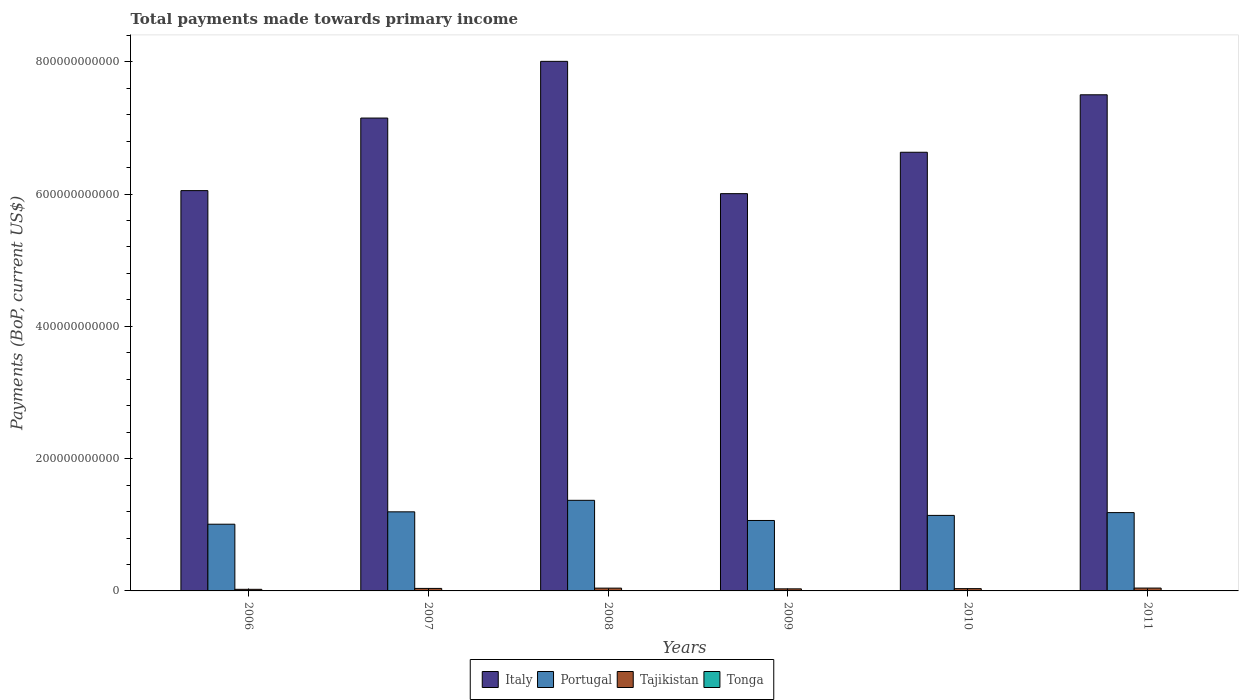How many groups of bars are there?
Your answer should be compact. 6. Are the number of bars on each tick of the X-axis equal?
Make the answer very short. Yes. In how many cases, is the number of bars for a given year not equal to the number of legend labels?
Ensure brevity in your answer.  0. What is the total payments made towards primary income in Tajikistan in 2006?
Your response must be concise. 2.43e+09. Across all years, what is the maximum total payments made towards primary income in Italy?
Keep it short and to the point. 8.01e+11. Across all years, what is the minimum total payments made towards primary income in Tajikistan?
Your response must be concise. 2.43e+09. In which year was the total payments made towards primary income in Tajikistan maximum?
Provide a succinct answer. 2011. What is the total total payments made towards primary income in Italy in the graph?
Ensure brevity in your answer.  4.13e+12. What is the difference between the total payments made towards primary income in Tajikistan in 2007 and that in 2010?
Make the answer very short. 3.23e+08. What is the difference between the total payments made towards primary income in Tonga in 2008 and the total payments made towards primary income in Tajikistan in 2010?
Your answer should be compact. -3.21e+09. What is the average total payments made towards primary income in Portugal per year?
Offer a very short reply. 1.16e+11. In the year 2008, what is the difference between the total payments made towards primary income in Italy and total payments made towards primary income in Portugal?
Give a very brief answer. 6.64e+11. In how many years, is the total payments made towards primary income in Tajikistan greater than 600000000000 US$?
Provide a succinct answer. 0. What is the ratio of the total payments made towards primary income in Italy in 2006 to that in 2010?
Your response must be concise. 0.91. Is the total payments made towards primary income in Tonga in 2009 less than that in 2010?
Provide a succinct answer. No. What is the difference between the highest and the second highest total payments made towards primary income in Italy?
Offer a terse response. 5.06e+1. What is the difference between the highest and the lowest total payments made towards primary income in Italy?
Keep it short and to the point. 2.00e+11. In how many years, is the total payments made towards primary income in Tajikistan greater than the average total payments made towards primary income in Tajikistan taken over all years?
Keep it short and to the point. 3. What does the 3rd bar from the left in 2010 represents?
Ensure brevity in your answer.  Tajikistan. What does the 3rd bar from the right in 2006 represents?
Make the answer very short. Portugal. Is it the case that in every year, the sum of the total payments made towards primary income in Italy and total payments made towards primary income in Tonga is greater than the total payments made towards primary income in Portugal?
Make the answer very short. Yes. Are all the bars in the graph horizontal?
Offer a terse response. No. How many years are there in the graph?
Offer a terse response. 6. What is the difference between two consecutive major ticks on the Y-axis?
Give a very brief answer. 2.00e+11. Does the graph contain grids?
Provide a succinct answer. No. Where does the legend appear in the graph?
Make the answer very short. Bottom center. How many legend labels are there?
Offer a very short reply. 4. How are the legend labels stacked?
Your answer should be very brief. Horizontal. What is the title of the graph?
Your answer should be compact. Total payments made towards primary income. Does "United Kingdom" appear as one of the legend labels in the graph?
Provide a succinct answer. No. What is the label or title of the X-axis?
Your answer should be very brief. Years. What is the label or title of the Y-axis?
Ensure brevity in your answer.  Payments (BoP, current US$). What is the Payments (BoP, current US$) of Italy in 2006?
Make the answer very short. 6.05e+11. What is the Payments (BoP, current US$) in Portugal in 2006?
Offer a very short reply. 1.01e+11. What is the Payments (BoP, current US$) in Tajikistan in 2006?
Give a very brief answer. 2.43e+09. What is the Payments (BoP, current US$) in Tonga in 2006?
Provide a short and direct response. 1.74e+08. What is the Payments (BoP, current US$) in Italy in 2007?
Provide a succinct answer. 7.15e+11. What is the Payments (BoP, current US$) in Portugal in 2007?
Your answer should be compact. 1.20e+11. What is the Payments (BoP, current US$) in Tajikistan in 2007?
Ensure brevity in your answer.  3.78e+09. What is the Payments (BoP, current US$) in Tonga in 2007?
Provide a succinct answer. 2.03e+08. What is the Payments (BoP, current US$) in Italy in 2008?
Make the answer very short. 8.01e+11. What is the Payments (BoP, current US$) of Portugal in 2008?
Make the answer very short. 1.37e+11. What is the Payments (BoP, current US$) of Tajikistan in 2008?
Make the answer very short. 4.23e+09. What is the Payments (BoP, current US$) in Tonga in 2008?
Your answer should be very brief. 2.51e+08. What is the Payments (BoP, current US$) of Italy in 2009?
Provide a succinct answer. 6.01e+11. What is the Payments (BoP, current US$) of Portugal in 2009?
Offer a very short reply. 1.07e+11. What is the Payments (BoP, current US$) in Tajikistan in 2009?
Make the answer very short. 3.14e+09. What is the Payments (BoP, current US$) in Tonga in 2009?
Offer a terse response. 2.45e+08. What is the Payments (BoP, current US$) in Italy in 2010?
Provide a short and direct response. 6.63e+11. What is the Payments (BoP, current US$) in Portugal in 2010?
Provide a short and direct response. 1.14e+11. What is the Payments (BoP, current US$) in Tajikistan in 2010?
Provide a short and direct response. 3.46e+09. What is the Payments (BoP, current US$) of Tonga in 2010?
Give a very brief answer. 2.33e+08. What is the Payments (BoP, current US$) of Italy in 2011?
Provide a succinct answer. 7.50e+11. What is the Payments (BoP, current US$) in Portugal in 2011?
Offer a very short reply. 1.18e+11. What is the Payments (BoP, current US$) of Tajikistan in 2011?
Your answer should be very brief. 4.32e+09. What is the Payments (BoP, current US$) in Tonga in 2011?
Your response must be concise. 2.87e+08. Across all years, what is the maximum Payments (BoP, current US$) in Italy?
Your answer should be very brief. 8.01e+11. Across all years, what is the maximum Payments (BoP, current US$) of Portugal?
Make the answer very short. 1.37e+11. Across all years, what is the maximum Payments (BoP, current US$) in Tajikistan?
Offer a very short reply. 4.32e+09. Across all years, what is the maximum Payments (BoP, current US$) in Tonga?
Offer a terse response. 2.87e+08. Across all years, what is the minimum Payments (BoP, current US$) of Italy?
Ensure brevity in your answer.  6.01e+11. Across all years, what is the minimum Payments (BoP, current US$) of Portugal?
Offer a terse response. 1.01e+11. Across all years, what is the minimum Payments (BoP, current US$) in Tajikistan?
Offer a very short reply. 2.43e+09. Across all years, what is the minimum Payments (BoP, current US$) of Tonga?
Provide a short and direct response. 1.74e+08. What is the total Payments (BoP, current US$) of Italy in the graph?
Offer a terse response. 4.13e+12. What is the total Payments (BoP, current US$) of Portugal in the graph?
Offer a terse response. 6.96e+11. What is the total Payments (BoP, current US$) in Tajikistan in the graph?
Offer a terse response. 2.13e+1. What is the total Payments (BoP, current US$) of Tonga in the graph?
Provide a succinct answer. 1.39e+09. What is the difference between the Payments (BoP, current US$) of Italy in 2006 and that in 2007?
Offer a terse response. -1.10e+11. What is the difference between the Payments (BoP, current US$) in Portugal in 2006 and that in 2007?
Ensure brevity in your answer.  -1.87e+1. What is the difference between the Payments (BoP, current US$) in Tajikistan in 2006 and that in 2007?
Offer a terse response. -1.35e+09. What is the difference between the Payments (BoP, current US$) in Tonga in 2006 and that in 2007?
Give a very brief answer. -2.93e+07. What is the difference between the Payments (BoP, current US$) in Italy in 2006 and that in 2008?
Your response must be concise. -1.95e+11. What is the difference between the Payments (BoP, current US$) in Portugal in 2006 and that in 2008?
Your response must be concise. -3.61e+1. What is the difference between the Payments (BoP, current US$) of Tajikistan in 2006 and that in 2008?
Give a very brief answer. -1.80e+09. What is the difference between the Payments (BoP, current US$) of Tonga in 2006 and that in 2008?
Give a very brief answer. -7.73e+07. What is the difference between the Payments (BoP, current US$) of Italy in 2006 and that in 2009?
Make the answer very short. 4.59e+09. What is the difference between the Payments (BoP, current US$) in Portugal in 2006 and that in 2009?
Make the answer very short. -5.64e+09. What is the difference between the Payments (BoP, current US$) in Tajikistan in 2006 and that in 2009?
Your answer should be very brief. -7.15e+08. What is the difference between the Payments (BoP, current US$) in Tonga in 2006 and that in 2009?
Ensure brevity in your answer.  -7.15e+07. What is the difference between the Payments (BoP, current US$) in Italy in 2006 and that in 2010?
Your response must be concise. -5.80e+1. What is the difference between the Payments (BoP, current US$) in Portugal in 2006 and that in 2010?
Make the answer very short. -1.33e+1. What is the difference between the Payments (BoP, current US$) in Tajikistan in 2006 and that in 2010?
Ensure brevity in your answer.  -1.03e+09. What is the difference between the Payments (BoP, current US$) of Tonga in 2006 and that in 2010?
Ensure brevity in your answer.  -5.87e+07. What is the difference between the Payments (BoP, current US$) of Italy in 2006 and that in 2011?
Your answer should be compact. -1.45e+11. What is the difference between the Payments (BoP, current US$) of Portugal in 2006 and that in 2011?
Give a very brief answer. -1.75e+1. What is the difference between the Payments (BoP, current US$) in Tajikistan in 2006 and that in 2011?
Offer a terse response. -1.89e+09. What is the difference between the Payments (BoP, current US$) of Tonga in 2006 and that in 2011?
Keep it short and to the point. -1.13e+08. What is the difference between the Payments (BoP, current US$) of Italy in 2007 and that in 2008?
Provide a short and direct response. -8.57e+1. What is the difference between the Payments (BoP, current US$) of Portugal in 2007 and that in 2008?
Your answer should be compact. -1.74e+1. What is the difference between the Payments (BoP, current US$) in Tajikistan in 2007 and that in 2008?
Your answer should be compact. -4.47e+08. What is the difference between the Payments (BoP, current US$) in Tonga in 2007 and that in 2008?
Make the answer very short. -4.80e+07. What is the difference between the Payments (BoP, current US$) in Italy in 2007 and that in 2009?
Offer a very short reply. 1.14e+11. What is the difference between the Payments (BoP, current US$) in Portugal in 2007 and that in 2009?
Ensure brevity in your answer.  1.31e+1. What is the difference between the Payments (BoP, current US$) in Tajikistan in 2007 and that in 2009?
Your response must be concise. 6.40e+08. What is the difference between the Payments (BoP, current US$) in Tonga in 2007 and that in 2009?
Offer a very short reply. -4.23e+07. What is the difference between the Payments (BoP, current US$) of Italy in 2007 and that in 2010?
Offer a terse response. 5.17e+1. What is the difference between the Payments (BoP, current US$) in Portugal in 2007 and that in 2010?
Your response must be concise. 5.39e+09. What is the difference between the Payments (BoP, current US$) in Tajikistan in 2007 and that in 2010?
Provide a short and direct response. 3.23e+08. What is the difference between the Payments (BoP, current US$) in Tonga in 2007 and that in 2010?
Keep it short and to the point. -2.95e+07. What is the difference between the Payments (BoP, current US$) of Italy in 2007 and that in 2011?
Give a very brief answer. -3.52e+1. What is the difference between the Payments (BoP, current US$) of Portugal in 2007 and that in 2011?
Your response must be concise. 1.15e+09. What is the difference between the Payments (BoP, current US$) in Tajikistan in 2007 and that in 2011?
Give a very brief answer. -5.39e+08. What is the difference between the Payments (BoP, current US$) in Tonga in 2007 and that in 2011?
Make the answer very short. -8.40e+07. What is the difference between the Payments (BoP, current US$) of Italy in 2008 and that in 2009?
Ensure brevity in your answer.  2.00e+11. What is the difference between the Payments (BoP, current US$) of Portugal in 2008 and that in 2009?
Offer a very short reply. 3.05e+1. What is the difference between the Payments (BoP, current US$) in Tajikistan in 2008 and that in 2009?
Your answer should be very brief. 1.09e+09. What is the difference between the Payments (BoP, current US$) in Tonga in 2008 and that in 2009?
Offer a very short reply. 5.78e+06. What is the difference between the Payments (BoP, current US$) in Italy in 2008 and that in 2010?
Make the answer very short. 1.37e+11. What is the difference between the Payments (BoP, current US$) of Portugal in 2008 and that in 2010?
Keep it short and to the point. 2.28e+1. What is the difference between the Payments (BoP, current US$) in Tajikistan in 2008 and that in 2010?
Your response must be concise. 7.69e+08. What is the difference between the Payments (BoP, current US$) of Tonga in 2008 and that in 2010?
Keep it short and to the point. 1.86e+07. What is the difference between the Payments (BoP, current US$) of Italy in 2008 and that in 2011?
Your answer should be compact. 5.06e+1. What is the difference between the Payments (BoP, current US$) of Portugal in 2008 and that in 2011?
Your answer should be very brief. 1.86e+1. What is the difference between the Payments (BoP, current US$) in Tajikistan in 2008 and that in 2011?
Offer a terse response. -9.22e+07. What is the difference between the Payments (BoP, current US$) in Tonga in 2008 and that in 2011?
Your answer should be compact. -3.60e+07. What is the difference between the Payments (BoP, current US$) of Italy in 2009 and that in 2010?
Make the answer very short. -6.26e+1. What is the difference between the Payments (BoP, current US$) in Portugal in 2009 and that in 2010?
Keep it short and to the point. -7.67e+09. What is the difference between the Payments (BoP, current US$) in Tajikistan in 2009 and that in 2010?
Offer a terse response. -3.17e+08. What is the difference between the Payments (BoP, current US$) in Tonga in 2009 and that in 2010?
Make the answer very short. 1.28e+07. What is the difference between the Payments (BoP, current US$) in Italy in 2009 and that in 2011?
Your answer should be very brief. -1.49e+11. What is the difference between the Payments (BoP, current US$) of Portugal in 2009 and that in 2011?
Your response must be concise. -1.19e+1. What is the difference between the Payments (BoP, current US$) of Tajikistan in 2009 and that in 2011?
Make the answer very short. -1.18e+09. What is the difference between the Payments (BoP, current US$) in Tonga in 2009 and that in 2011?
Keep it short and to the point. -4.18e+07. What is the difference between the Payments (BoP, current US$) of Italy in 2010 and that in 2011?
Provide a succinct answer. -8.69e+1. What is the difference between the Payments (BoP, current US$) in Portugal in 2010 and that in 2011?
Provide a short and direct response. -4.24e+09. What is the difference between the Payments (BoP, current US$) in Tajikistan in 2010 and that in 2011?
Your answer should be compact. -8.61e+08. What is the difference between the Payments (BoP, current US$) of Tonga in 2010 and that in 2011?
Make the answer very short. -5.46e+07. What is the difference between the Payments (BoP, current US$) in Italy in 2006 and the Payments (BoP, current US$) in Portugal in 2007?
Your answer should be compact. 4.86e+11. What is the difference between the Payments (BoP, current US$) of Italy in 2006 and the Payments (BoP, current US$) of Tajikistan in 2007?
Offer a terse response. 6.01e+11. What is the difference between the Payments (BoP, current US$) in Italy in 2006 and the Payments (BoP, current US$) in Tonga in 2007?
Ensure brevity in your answer.  6.05e+11. What is the difference between the Payments (BoP, current US$) of Portugal in 2006 and the Payments (BoP, current US$) of Tajikistan in 2007?
Your answer should be compact. 9.71e+1. What is the difference between the Payments (BoP, current US$) in Portugal in 2006 and the Payments (BoP, current US$) in Tonga in 2007?
Make the answer very short. 1.01e+11. What is the difference between the Payments (BoP, current US$) of Tajikistan in 2006 and the Payments (BoP, current US$) of Tonga in 2007?
Give a very brief answer. 2.22e+09. What is the difference between the Payments (BoP, current US$) of Italy in 2006 and the Payments (BoP, current US$) of Portugal in 2008?
Provide a succinct answer. 4.68e+11. What is the difference between the Payments (BoP, current US$) of Italy in 2006 and the Payments (BoP, current US$) of Tajikistan in 2008?
Give a very brief answer. 6.01e+11. What is the difference between the Payments (BoP, current US$) in Italy in 2006 and the Payments (BoP, current US$) in Tonga in 2008?
Offer a very short reply. 6.05e+11. What is the difference between the Payments (BoP, current US$) of Portugal in 2006 and the Payments (BoP, current US$) of Tajikistan in 2008?
Provide a short and direct response. 9.66e+1. What is the difference between the Payments (BoP, current US$) of Portugal in 2006 and the Payments (BoP, current US$) of Tonga in 2008?
Give a very brief answer. 1.01e+11. What is the difference between the Payments (BoP, current US$) in Tajikistan in 2006 and the Payments (BoP, current US$) in Tonga in 2008?
Make the answer very short. 2.17e+09. What is the difference between the Payments (BoP, current US$) in Italy in 2006 and the Payments (BoP, current US$) in Portugal in 2009?
Your answer should be very brief. 4.99e+11. What is the difference between the Payments (BoP, current US$) in Italy in 2006 and the Payments (BoP, current US$) in Tajikistan in 2009?
Keep it short and to the point. 6.02e+11. What is the difference between the Payments (BoP, current US$) of Italy in 2006 and the Payments (BoP, current US$) of Tonga in 2009?
Your answer should be compact. 6.05e+11. What is the difference between the Payments (BoP, current US$) in Portugal in 2006 and the Payments (BoP, current US$) in Tajikistan in 2009?
Ensure brevity in your answer.  9.77e+1. What is the difference between the Payments (BoP, current US$) in Portugal in 2006 and the Payments (BoP, current US$) in Tonga in 2009?
Provide a succinct answer. 1.01e+11. What is the difference between the Payments (BoP, current US$) of Tajikistan in 2006 and the Payments (BoP, current US$) of Tonga in 2009?
Your answer should be compact. 2.18e+09. What is the difference between the Payments (BoP, current US$) of Italy in 2006 and the Payments (BoP, current US$) of Portugal in 2010?
Keep it short and to the point. 4.91e+11. What is the difference between the Payments (BoP, current US$) in Italy in 2006 and the Payments (BoP, current US$) in Tajikistan in 2010?
Offer a terse response. 6.02e+11. What is the difference between the Payments (BoP, current US$) of Italy in 2006 and the Payments (BoP, current US$) of Tonga in 2010?
Provide a succinct answer. 6.05e+11. What is the difference between the Payments (BoP, current US$) in Portugal in 2006 and the Payments (BoP, current US$) in Tajikistan in 2010?
Make the answer very short. 9.74e+1. What is the difference between the Payments (BoP, current US$) in Portugal in 2006 and the Payments (BoP, current US$) in Tonga in 2010?
Your answer should be very brief. 1.01e+11. What is the difference between the Payments (BoP, current US$) in Tajikistan in 2006 and the Payments (BoP, current US$) in Tonga in 2010?
Make the answer very short. 2.19e+09. What is the difference between the Payments (BoP, current US$) of Italy in 2006 and the Payments (BoP, current US$) of Portugal in 2011?
Offer a terse response. 4.87e+11. What is the difference between the Payments (BoP, current US$) in Italy in 2006 and the Payments (BoP, current US$) in Tajikistan in 2011?
Provide a succinct answer. 6.01e+11. What is the difference between the Payments (BoP, current US$) in Italy in 2006 and the Payments (BoP, current US$) in Tonga in 2011?
Provide a succinct answer. 6.05e+11. What is the difference between the Payments (BoP, current US$) in Portugal in 2006 and the Payments (BoP, current US$) in Tajikistan in 2011?
Keep it short and to the point. 9.65e+1. What is the difference between the Payments (BoP, current US$) of Portugal in 2006 and the Payments (BoP, current US$) of Tonga in 2011?
Offer a terse response. 1.01e+11. What is the difference between the Payments (BoP, current US$) of Tajikistan in 2006 and the Payments (BoP, current US$) of Tonga in 2011?
Make the answer very short. 2.14e+09. What is the difference between the Payments (BoP, current US$) in Italy in 2007 and the Payments (BoP, current US$) in Portugal in 2008?
Give a very brief answer. 5.78e+11. What is the difference between the Payments (BoP, current US$) of Italy in 2007 and the Payments (BoP, current US$) of Tajikistan in 2008?
Your answer should be compact. 7.11e+11. What is the difference between the Payments (BoP, current US$) of Italy in 2007 and the Payments (BoP, current US$) of Tonga in 2008?
Give a very brief answer. 7.15e+11. What is the difference between the Payments (BoP, current US$) in Portugal in 2007 and the Payments (BoP, current US$) in Tajikistan in 2008?
Ensure brevity in your answer.  1.15e+11. What is the difference between the Payments (BoP, current US$) of Portugal in 2007 and the Payments (BoP, current US$) of Tonga in 2008?
Ensure brevity in your answer.  1.19e+11. What is the difference between the Payments (BoP, current US$) of Tajikistan in 2007 and the Payments (BoP, current US$) of Tonga in 2008?
Ensure brevity in your answer.  3.53e+09. What is the difference between the Payments (BoP, current US$) of Italy in 2007 and the Payments (BoP, current US$) of Portugal in 2009?
Your answer should be very brief. 6.08e+11. What is the difference between the Payments (BoP, current US$) of Italy in 2007 and the Payments (BoP, current US$) of Tajikistan in 2009?
Give a very brief answer. 7.12e+11. What is the difference between the Payments (BoP, current US$) in Italy in 2007 and the Payments (BoP, current US$) in Tonga in 2009?
Give a very brief answer. 7.15e+11. What is the difference between the Payments (BoP, current US$) of Portugal in 2007 and the Payments (BoP, current US$) of Tajikistan in 2009?
Give a very brief answer. 1.16e+11. What is the difference between the Payments (BoP, current US$) in Portugal in 2007 and the Payments (BoP, current US$) in Tonga in 2009?
Ensure brevity in your answer.  1.19e+11. What is the difference between the Payments (BoP, current US$) in Tajikistan in 2007 and the Payments (BoP, current US$) in Tonga in 2009?
Provide a short and direct response. 3.53e+09. What is the difference between the Payments (BoP, current US$) of Italy in 2007 and the Payments (BoP, current US$) of Portugal in 2010?
Your answer should be compact. 6.01e+11. What is the difference between the Payments (BoP, current US$) of Italy in 2007 and the Payments (BoP, current US$) of Tajikistan in 2010?
Your answer should be very brief. 7.11e+11. What is the difference between the Payments (BoP, current US$) of Italy in 2007 and the Payments (BoP, current US$) of Tonga in 2010?
Ensure brevity in your answer.  7.15e+11. What is the difference between the Payments (BoP, current US$) of Portugal in 2007 and the Payments (BoP, current US$) of Tajikistan in 2010?
Your response must be concise. 1.16e+11. What is the difference between the Payments (BoP, current US$) in Portugal in 2007 and the Payments (BoP, current US$) in Tonga in 2010?
Your answer should be compact. 1.19e+11. What is the difference between the Payments (BoP, current US$) in Tajikistan in 2007 and the Payments (BoP, current US$) in Tonga in 2010?
Your response must be concise. 3.55e+09. What is the difference between the Payments (BoP, current US$) of Italy in 2007 and the Payments (BoP, current US$) of Portugal in 2011?
Give a very brief answer. 5.96e+11. What is the difference between the Payments (BoP, current US$) of Italy in 2007 and the Payments (BoP, current US$) of Tajikistan in 2011?
Provide a succinct answer. 7.11e+11. What is the difference between the Payments (BoP, current US$) in Italy in 2007 and the Payments (BoP, current US$) in Tonga in 2011?
Ensure brevity in your answer.  7.15e+11. What is the difference between the Payments (BoP, current US$) in Portugal in 2007 and the Payments (BoP, current US$) in Tajikistan in 2011?
Offer a very short reply. 1.15e+11. What is the difference between the Payments (BoP, current US$) in Portugal in 2007 and the Payments (BoP, current US$) in Tonga in 2011?
Provide a succinct answer. 1.19e+11. What is the difference between the Payments (BoP, current US$) in Tajikistan in 2007 and the Payments (BoP, current US$) in Tonga in 2011?
Give a very brief answer. 3.49e+09. What is the difference between the Payments (BoP, current US$) in Italy in 2008 and the Payments (BoP, current US$) in Portugal in 2009?
Keep it short and to the point. 6.94e+11. What is the difference between the Payments (BoP, current US$) in Italy in 2008 and the Payments (BoP, current US$) in Tajikistan in 2009?
Your answer should be very brief. 7.97e+11. What is the difference between the Payments (BoP, current US$) in Italy in 2008 and the Payments (BoP, current US$) in Tonga in 2009?
Provide a short and direct response. 8.00e+11. What is the difference between the Payments (BoP, current US$) in Portugal in 2008 and the Payments (BoP, current US$) in Tajikistan in 2009?
Offer a terse response. 1.34e+11. What is the difference between the Payments (BoP, current US$) in Portugal in 2008 and the Payments (BoP, current US$) in Tonga in 2009?
Your response must be concise. 1.37e+11. What is the difference between the Payments (BoP, current US$) in Tajikistan in 2008 and the Payments (BoP, current US$) in Tonga in 2009?
Make the answer very short. 3.98e+09. What is the difference between the Payments (BoP, current US$) of Italy in 2008 and the Payments (BoP, current US$) of Portugal in 2010?
Keep it short and to the point. 6.86e+11. What is the difference between the Payments (BoP, current US$) in Italy in 2008 and the Payments (BoP, current US$) in Tajikistan in 2010?
Offer a very short reply. 7.97e+11. What is the difference between the Payments (BoP, current US$) of Italy in 2008 and the Payments (BoP, current US$) of Tonga in 2010?
Your answer should be very brief. 8.00e+11. What is the difference between the Payments (BoP, current US$) of Portugal in 2008 and the Payments (BoP, current US$) of Tajikistan in 2010?
Provide a succinct answer. 1.34e+11. What is the difference between the Payments (BoP, current US$) in Portugal in 2008 and the Payments (BoP, current US$) in Tonga in 2010?
Your answer should be compact. 1.37e+11. What is the difference between the Payments (BoP, current US$) in Tajikistan in 2008 and the Payments (BoP, current US$) in Tonga in 2010?
Your response must be concise. 3.99e+09. What is the difference between the Payments (BoP, current US$) in Italy in 2008 and the Payments (BoP, current US$) in Portugal in 2011?
Provide a succinct answer. 6.82e+11. What is the difference between the Payments (BoP, current US$) in Italy in 2008 and the Payments (BoP, current US$) in Tajikistan in 2011?
Your response must be concise. 7.96e+11. What is the difference between the Payments (BoP, current US$) in Italy in 2008 and the Payments (BoP, current US$) in Tonga in 2011?
Offer a terse response. 8.00e+11. What is the difference between the Payments (BoP, current US$) in Portugal in 2008 and the Payments (BoP, current US$) in Tajikistan in 2011?
Your answer should be very brief. 1.33e+11. What is the difference between the Payments (BoP, current US$) of Portugal in 2008 and the Payments (BoP, current US$) of Tonga in 2011?
Keep it short and to the point. 1.37e+11. What is the difference between the Payments (BoP, current US$) in Tajikistan in 2008 and the Payments (BoP, current US$) in Tonga in 2011?
Make the answer very short. 3.94e+09. What is the difference between the Payments (BoP, current US$) in Italy in 2009 and the Payments (BoP, current US$) in Portugal in 2010?
Provide a short and direct response. 4.86e+11. What is the difference between the Payments (BoP, current US$) in Italy in 2009 and the Payments (BoP, current US$) in Tajikistan in 2010?
Your response must be concise. 5.97e+11. What is the difference between the Payments (BoP, current US$) in Italy in 2009 and the Payments (BoP, current US$) in Tonga in 2010?
Provide a succinct answer. 6.00e+11. What is the difference between the Payments (BoP, current US$) in Portugal in 2009 and the Payments (BoP, current US$) in Tajikistan in 2010?
Your answer should be compact. 1.03e+11. What is the difference between the Payments (BoP, current US$) in Portugal in 2009 and the Payments (BoP, current US$) in Tonga in 2010?
Keep it short and to the point. 1.06e+11. What is the difference between the Payments (BoP, current US$) of Tajikistan in 2009 and the Payments (BoP, current US$) of Tonga in 2010?
Make the answer very short. 2.91e+09. What is the difference between the Payments (BoP, current US$) of Italy in 2009 and the Payments (BoP, current US$) of Portugal in 2011?
Provide a succinct answer. 4.82e+11. What is the difference between the Payments (BoP, current US$) in Italy in 2009 and the Payments (BoP, current US$) in Tajikistan in 2011?
Offer a very short reply. 5.96e+11. What is the difference between the Payments (BoP, current US$) in Italy in 2009 and the Payments (BoP, current US$) in Tonga in 2011?
Provide a succinct answer. 6.00e+11. What is the difference between the Payments (BoP, current US$) of Portugal in 2009 and the Payments (BoP, current US$) of Tajikistan in 2011?
Provide a succinct answer. 1.02e+11. What is the difference between the Payments (BoP, current US$) of Portugal in 2009 and the Payments (BoP, current US$) of Tonga in 2011?
Offer a terse response. 1.06e+11. What is the difference between the Payments (BoP, current US$) in Tajikistan in 2009 and the Payments (BoP, current US$) in Tonga in 2011?
Offer a very short reply. 2.85e+09. What is the difference between the Payments (BoP, current US$) of Italy in 2010 and the Payments (BoP, current US$) of Portugal in 2011?
Provide a short and direct response. 5.45e+11. What is the difference between the Payments (BoP, current US$) in Italy in 2010 and the Payments (BoP, current US$) in Tajikistan in 2011?
Provide a short and direct response. 6.59e+11. What is the difference between the Payments (BoP, current US$) of Italy in 2010 and the Payments (BoP, current US$) of Tonga in 2011?
Ensure brevity in your answer.  6.63e+11. What is the difference between the Payments (BoP, current US$) in Portugal in 2010 and the Payments (BoP, current US$) in Tajikistan in 2011?
Your answer should be compact. 1.10e+11. What is the difference between the Payments (BoP, current US$) in Portugal in 2010 and the Payments (BoP, current US$) in Tonga in 2011?
Keep it short and to the point. 1.14e+11. What is the difference between the Payments (BoP, current US$) in Tajikistan in 2010 and the Payments (BoP, current US$) in Tonga in 2011?
Give a very brief answer. 3.17e+09. What is the average Payments (BoP, current US$) of Italy per year?
Your answer should be compact. 6.89e+11. What is the average Payments (BoP, current US$) of Portugal per year?
Provide a short and direct response. 1.16e+11. What is the average Payments (BoP, current US$) in Tajikistan per year?
Your answer should be compact. 3.56e+09. What is the average Payments (BoP, current US$) of Tonga per year?
Keep it short and to the point. 2.32e+08. In the year 2006, what is the difference between the Payments (BoP, current US$) of Italy and Payments (BoP, current US$) of Portugal?
Your response must be concise. 5.04e+11. In the year 2006, what is the difference between the Payments (BoP, current US$) in Italy and Payments (BoP, current US$) in Tajikistan?
Provide a succinct answer. 6.03e+11. In the year 2006, what is the difference between the Payments (BoP, current US$) of Italy and Payments (BoP, current US$) of Tonga?
Provide a short and direct response. 6.05e+11. In the year 2006, what is the difference between the Payments (BoP, current US$) of Portugal and Payments (BoP, current US$) of Tajikistan?
Keep it short and to the point. 9.84e+1. In the year 2006, what is the difference between the Payments (BoP, current US$) of Portugal and Payments (BoP, current US$) of Tonga?
Keep it short and to the point. 1.01e+11. In the year 2006, what is the difference between the Payments (BoP, current US$) of Tajikistan and Payments (BoP, current US$) of Tonga?
Offer a terse response. 2.25e+09. In the year 2007, what is the difference between the Payments (BoP, current US$) in Italy and Payments (BoP, current US$) in Portugal?
Your answer should be compact. 5.95e+11. In the year 2007, what is the difference between the Payments (BoP, current US$) of Italy and Payments (BoP, current US$) of Tajikistan?
Give a very brief answer. 7.11e+11. In the year 2007, what is the difference between the Payments (BoP, current US$) of Italy and Payments (BoP, current US$) of Tonga?
Your answer should be compact. 7.15e+11. In the year 2007, what is the difference between the Payments (BoP, current US$) in Portugal and Payments (BoP, current US$) in Tajikistan?
Make the answer very short. 1.16e+11. In the year 2007, what is the difference between the Payments (BoP, current US$) in Portugal and Payments (BoP, current US$) in Tonga?
Ensure brevity in your answer.  1.19e+11. In the year 2007, what is the difference between the Payments (BoP, current US$) in Tajikistan and Payments (BoP, current US$) in Tonga?
Provide a short and direct response. 3.58e+09. In the year 2008, what is the difference between the Payments (BoP, current US$) of Italy and Payments (BoP, current US$) of Portugal?
Your answer should be very brief. 6.64e+11. In the year 2008, what is the difference between the Payments (BoP, current US$) in Italy and Payments (BoP, current US$) in Tajikistan?
Your answer should be very brief. 7.96e+11. In the year 2008, what is the difference between the Payments (BoP, current US$) of Italy and Payments (BoP, current US$) of Tonga?
Give a very brief answer. 8.00e+11. In the year 2008, what is the difference between the Payments (BoP, current US$) of Portugal and Payments (BoP, current US$) of Tajikistan?
Your response must be concise. 1.33e+11. In the year 2008, what is the difference between the Payments (BoP, current US$) in Portugal and Payments (BoP, current US$) in Tonga?
Give a very brief answer. 1.37e+11. In the year 2008, what is the difference between the Payments (BoP, current US$) in Tajikistan and Payments (BoP, current US$) in Tonga?
Your answer should be very brief. 3.98e+09. In the year 2009, what is the difference between the Payments (BoP, current US$) in Italy and Payments (BoP, current US$) in Portugal?
Make the answer very short. 4.94e+11. In the year 2009, what is the difference between the Payments (BoP, current US$) of Italy and Payments (BoP, current US$) of Tajikistan?
Keep it short and to the point. 5.97e+11. In the year 2009, what is the difference between the Payments (BoP, current US$) in Italy and Payments (BoP, current US$) in Tonga?
Offer a very short reply. 6.00e+11. In the year 2009, what is the difference between the Payments (BoP, current US$) of Portugal and Payments (BoP, current US$) of Tajikistan?
Your response must be concise. 1.03e+11. In the year 2009, what is the difference between the Payments (BoP, current US$) in Portugal and Payments (BoP, current US$) in Tonga?
Give a very brief answer. 1.06e+11. In the year 2009, what is the difference between the Payments (BoP, current US$) of Tajikistan and Payments (BoP, current US$) of Tonga?
Give a very brief answer. 2.90e+09. In the year 2010, what is the difference between the Payments (BoP, current US$) of Italy and Payments (BoP, current US$) of Portugal?
Keep it short and to the point. 5.49e+11. In the year 2010, what is the difference between the Payments (BoP, current US$) in Italy and Payments (BoP, current US$) in Tajikistan?
Ensure brevity in your answer.  6.60e+11. In the year 2010, what is the difference between the Payments (BoP, current US$) in Italy and Payments (BoP, current US$) in Tonga?
Keep it short and to the point. 6.63e+11. In the year 2010, what is the difference between the Payments (BoP, current US$) of Portugal and Payments (BoP, current US$) of Tajikistan?
Provide a succinct answer. 1.11e+11. In the year 2010, what is the difference between the Payments (BoP, current US$) of Portugal and Payments (BoP, current US$) of Tonga?
Offer a terse response. 1.14e+11. In the year 2010, what is the difference between the Payments (BoP, current US$) in Tajikistan and Payments (BoP, current US$) in Tonga?
Your answer should be very brief. 3.22e+09. In the year 2011, what is the difference between the Payments (BoP, current US$) in Italy and Payments (BoP, current US$) in Portugal?
Your answer should be compact. 6.32e+11. In the year 2011, what is the difference between the Payments (BoP, current US$) in Italy and Payments (BoP, current US$) in Tajikistan?
Provide a succinct answer. 7.46e+11. In the year 2011, what is the difference between the Payments (BoP, current US$) of Italy and Payments (BoP, current US$) of Tonga?
Offer a very short reply. 7.50e+11. In the year 2011, what is the difference between the Payments (BoP, current US$) of Portugal and Payments (BoP, current US$) of Tajikistan?
Offer a very short reply. 1.14e+11. In the year 2011, what is the difference between the Payments (BoP, current US$) in Portugal and Payments (BoP, current US$) in Tonga?
Give a very brief answer. 1.18e+11. In the year 2011, what is the difference between the Payments (BoP, current US$) of Tajikistan and Payments (BoP, current US$) of Tonga?
Provide a short and direct response. 4.03e+09. What is the ratio of the Payments (BoP, current US$) of Italy in 2006 to that in 2007?
Your answer should be very brief. 0.85. What is the ratio of the Payments (BoP, current US$) in Portugal in 2006 to that in 2007?
Your answer should be compact. 0.84. What is the ratio of the Payments (BoP, current US$) of Tajikistan in 2006 to that in 2007?
Make the answer very short. 0.64. What is the ratio of the Payments (BoP, current US$) of Tonga in 2006 to that in 2007?
Provide a succinct answer. 0.86. What is the ratio of the Payments (BoP, current US$) of Italy in 2006 to that in 2008?
Offer a very short reply. 0.76. What is the ratio of the Payments (BoP, current US$) of Portugal in 2006 to that in 2008?
Provide a succinct answer. 0.74. What is the ratio of the Payments (BoP, current US$) of Tajikistan in 2006 to that in 2008?
Your answer should be very brief. 0.57. What is the ratio of the Payments (BoP, current US$) in Tonga in 2006 to that in 2008?
Offer a very short reply. 0.69. What is the ratio of the Payments (BoP, current US$) in Italy in 2006 to that in 2009?
Make the answer very short. 1.01. What is the ratio of the Payments (BoP, current US$) of Portugal in 2006 to that in 2009?
Give a very brief answer. 0.95. What is the ratio of the Payments (BoP, current US$) of Tajikistan in 2006 to that in 2009?
Keep it short and to the point. 0.77. What is the ratio of the Payments (BoP, current US$) of Tonga in 2006 to that in 2009?
Give a very brief answer. 0.71. What is the ratio of the Payments (BoP, current US$) of Italy in 2006 to that in 2010?
Your answer should be compact. 0.91. What is the ratio of the Payments (BoP, current US$) of Portugal in 2006 to that in 2010?
Provide a succinct answer. 0.88. What is the ratio of the Payments (BoP, current US$) in Tajikistan in 2006 to that in 2010?
Make the answer very short. 0.7. What is the ratio of the Payments (BoP, current US$) of Tonga in 2006 to that in 2010?
Make the answer very short. 0.75. What is the ratio of the Payments (BoP, current US$) of Italy in 2006 to that in 2011?
Provide a succinct answer. 0.81. What is the ratio of the Payments (BoP, current US$) in Portugal in 2006 to that in 2011?
Provide a succinct answer. 0.85. What is the ratio of the Payments (BoP, current US$) in Tajikistan in 2006 to that in 2011?
Make the answer very short. 0.56. What is the ratio of the Payments (BoP, current US$) in Tonga in 2006 to that in 2011?
Provide a short and direct response. 0.61. What is the ratio of the Payments (BoP, current US$) in Italy in 2007 to that in 2008?
Your answer should be compact. 0.89. What is the ratio of the Payments (BoP, current US$) in Portugal in 2007 to that in 2008?
Keep it short and to the point. 0.87. What is the ratio of the Payments (BoP, current US$) of Tajikistan in 2007 to that in 2008?
Offer a very short reply. 0.89. What is the ratio of the Payments (BoP, current US$) of Tonga in 2007 to that in 2008?
Provide a short and direct response. 0.81. What is the ratio of the Payments (BoP, current US$) of Italy in 2007 to that in 2009?
Ensure brevity in your answer.  1.19. What is the ratio of the Payments (BoP, current US$) in Portugal in 2007 to that in 2009?
Offer a very short reply. 1.12. What is the ratio of the Payments (BoP, current US$) in Tajikistan in 2007 to that in 2009?
Make the answer very short. 1.2. What is the ratio of the Payments (BoP, current US$) of Tonga in 2007 to that in 2009?
Provide a short and direct response. 0.83. What is the ratio of the Payments (BoP, current US$) in Italy in 2007 to that in 2010?
Provide a short and direct response. 1.08. What is the ratio of the Payments (BoP, current US$) in Portugal in 2007 to that in 2010?
Your answer should be very brief. 1.05. What is the ratio of the Payments (BoP, current US$) of Tajikistan in 2007 to that in 2010?
Offer a terse response. 1.09. What is the ratio of the Payments (BoP, current US$) in Tonga in 2007 to that in 2010?
Your answer should be compact. 0.87. What is the ratio of the Payments (BoP, current US$) of Italy in 2007 to that in 2011?
Offer a terse response. 0.95. What is the ratio of the Payments (BoP, current US$) of Portugal in 2007 to that in 2011?
Offer a terse response. 1.01. What is the ratio of the Payments (BoP, current US$) in Tajikistan in 2007 to that in 2011?
Ensure brevity in your answer.  0.88. What is the ratio of the Payments (BoP, current US$) of Tonga in 2007 to that in 2011?
Offer a terse response. 0.71. What is the ratio of the Payments (BoP, current US$) of Italy in 2008 to that in 2009?
Your answer should be compact. 1.33. What is the ratio of the Payments (BoP, current US$) in Portugal in 2008 to that in 2009?
Give a very brief answer. 1.29. What is the ratio of the Payments (BoP, current US$) of Tajikistan in 2008 to that in 2009?
Make the answer very short. 1.35. What is the ratio of the Payments (BoP, current US$) in Tonga in 2008 to that in 2009?
Offer a very short reply. 1.02. What is the ratio of the Payments (BoP, current US$) of Italy in 2008 to that in 2010?
Provide a succinct answer. 1.21. What is the ratio of the Payments (BoP, current US$) of Portugal in 2008 to that in 2010?
Your answer should be very brief. 1.2. What is the ratio of the Payments (BoP, current US$) of Tajikistan in 2008 to that in 2010?
Your response must be concise. 1.22. What is the ratio of the Payments (BoP, current US$) of Tonga in 2008 to that in 2010?
Your answer should be very brief. 1.08. What is the ratio of the Payments (BoP, current US$) in Italy in 2008 to that in 2011?
Provide a short and direct response. 1.07. What is the ratio of the Payments (BoP, current US$) of Portugal in 2008 to that in 2011?
Ensure brevity in your answer.  1.16. What is the ratio of the Payments (BoP, current US$) of Tajikistan in 2008 to that in 2011?
Give a very brief answer. 0.98. What is the ratio of the Payments (BoP, current US$) in Tonga in 2008 to that in 2011?
Ensure brevity in your answer.  0.87. What is the ratio of the Payments (BoP, current US$) in Italy in 2009 to that in 2010?
Provide a short and direct response. 0.91. What is the ratio of the Payments (BoP, current US$) in Portugal in 2009 to that in 2010?
Your answer should be compact. 0.93. What is the ratio of the Payments (BoP, current US$) in Tajikistan in 2009 to that in 2010?
Provide a succinct answer. 0.91. What is the ratio of the Payments (BoP, current US$) in Tonga in 2009 to that in 2010?
Provide a succinct answer. 1.05. What is the ratio of the Payments (BoP, current US$) in Italy in 2009 to that in 2011?
Offer a terse response. 0.8. What is the ratio of the Payments (BoP, current US$) in Portugal in 2009 to that in 2011?
Your answer should be compact. 0.9. What is the ratio of the Payments (BoP, current US$) in Tajikistan in 2009 to that in 2011?
Provide a succinct answer. 0.73. What is the ratio of the Payments (BoP, current US$) of Tonga in 2009 to that in 2011?
Provide a short and direct response. 0.85. What is the ratio of the Payments (BoP, current US$) of Italy in 2010 to that in 2011?
Provide a short and direct response. 0.88. What is the ratio of the Payments (BoP, current US$) in Portugal in 2010 to that in 2011?
Provide a short and direct response. 0.96. What is the ratio of the Payments (BoP, current US$) in Tajikistan in 2010 to that in 2011?
Your answer should be very brief. 0.8. What is the ratio of the Payments (BoP, current US$) of Tonga in 2010 to that in 2011?
Your response must be concise. 0.81. What is the difference between the highest and the second highest Payments (BoP, current US$) of Italy?
Keep it short and to the point. 5.06e+1. What is the difference between the highest and the second highest Payments (BoP, current US$) in Portugal?
Offer a very short reply. 1.74e+1. What is the difference between the highest and the second highest Payments (BoP, current US$) of Tajikistan?
Offer a terse response. 9.22e+07. What is the difference between the highest and the second highest Payments (BoP, current US$) in Tonga?
Make the answer very short. 3.60e+07. What is the difference between the highest and the lowest Payments (BoP, current US$) in Italy?
Provide a short and direct response. 2.00e+11. What is the difference between the highest and the lowest Payments (BoP, current US$) of Portugal?
Provide a short and direct response. 3.61e+1. What is the difference between the highest and the lowest Payments (BoP, current US$) in Tajikistan?
Keep it short and to the point. 1.89e+09. What is the difference between the highest and the lowest Payments (BoP, current US$) of Tonga?
Your answer should be compact. 1.13e+08. 